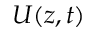<formula> <loc_0><loc_0><loc_500><loc_500>U ( z , t )</formula> 